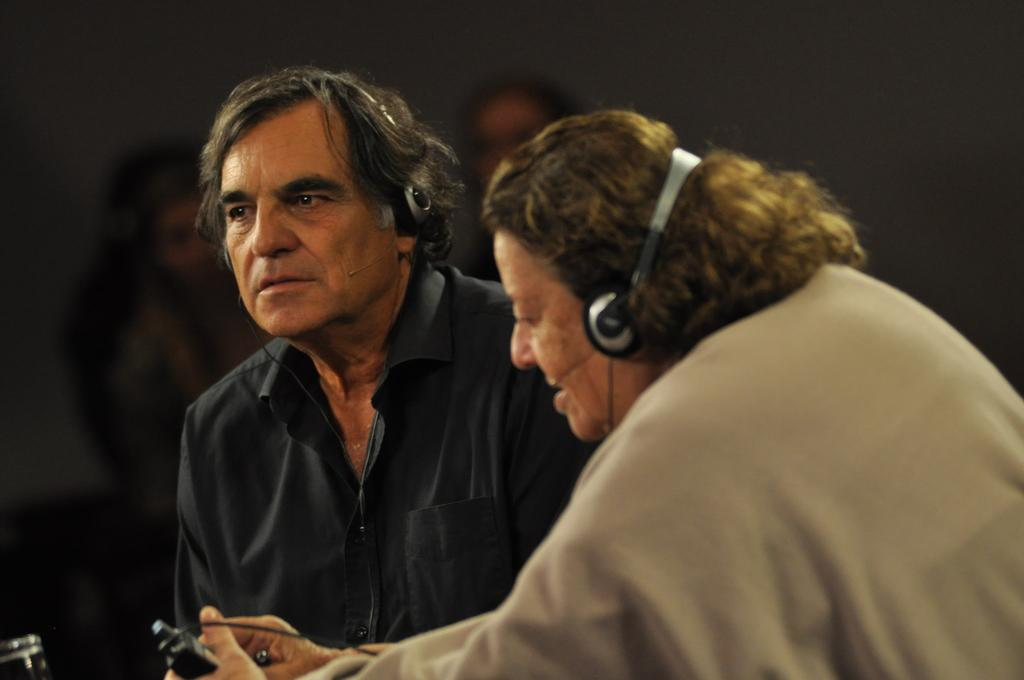How many people are in the image? There are people in the image, but the exact number is not specified. What is one person doing in the image? One person is holding an object in the image. Can you describe the background of the image? The background of the image is blurred. What can be seen in the bottom left corner of the image? There is an object in the bottom left corner of the image. What type of cream can be seen oozing out of the hole in the image? There is no hole or cream present in the image. 